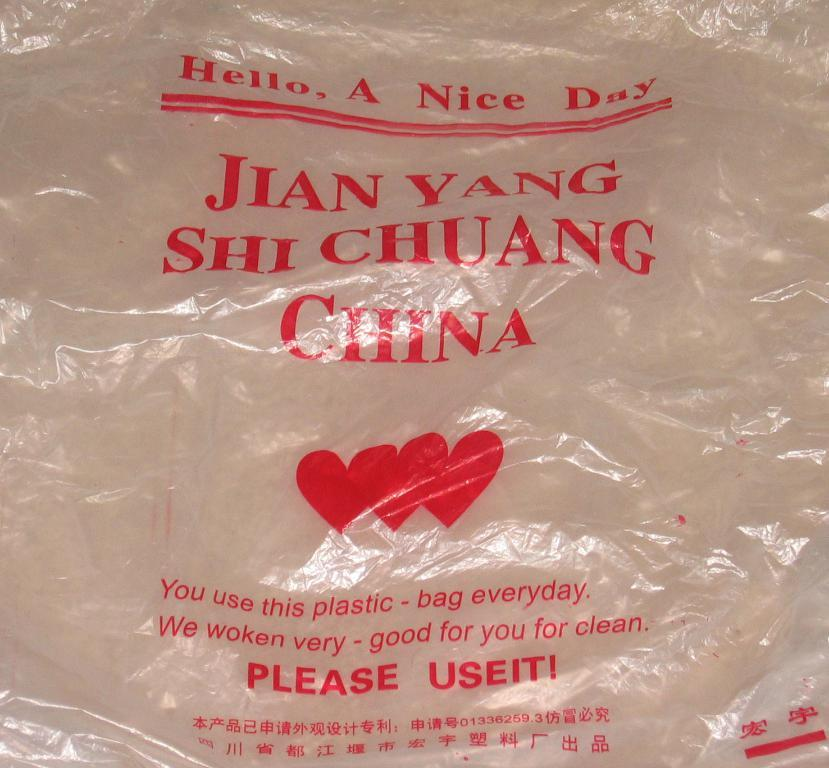What type of material is used to cover the object in the image? There is a polythene cover in the image. Can you describe any text or symbols on the polythene cover? The polythene cover has red writing on it, and there are heart shape symbols on it. What type of roof is visible on the company building in the image? There is no company building or roof present in the image; it only features a polythene cover with red writing and heart shape symbols. 